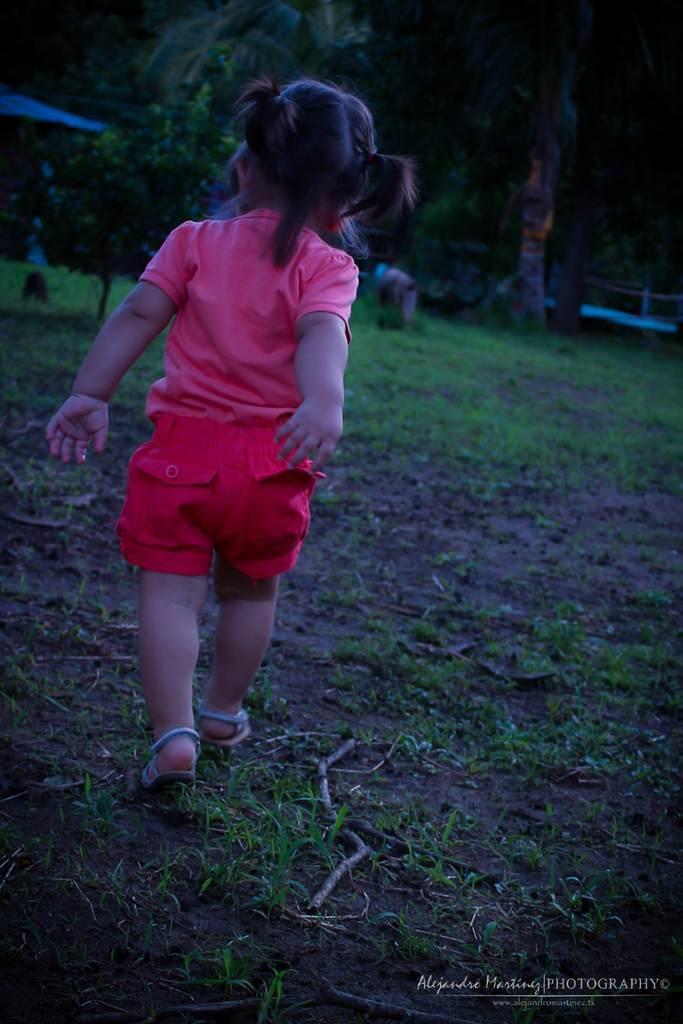Describe this image in one or two sentences. In this image we can see one girl walking on the ground, some text on the bottom right side of the image, one dried stem on the ground, few objects on the ground, one object looks like tent on the left side of the image, it looks like a fence in the background near the trees, some trees and grass on the ground. 